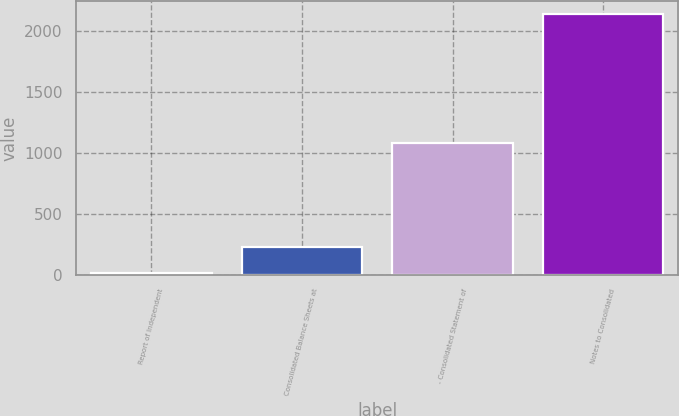Convert chart. <chart><loc_0><loc_0><loc_500><loc_500><bar_chart><fcel>Report of Independent<fcel>Consolidated Balance Sheets at<fcel>- Consolidated Statement of<fcel>Notes to Consolidated<nl><fcel>16<fcel>228<fcel>1076<fcel>2136<nl></chart> 